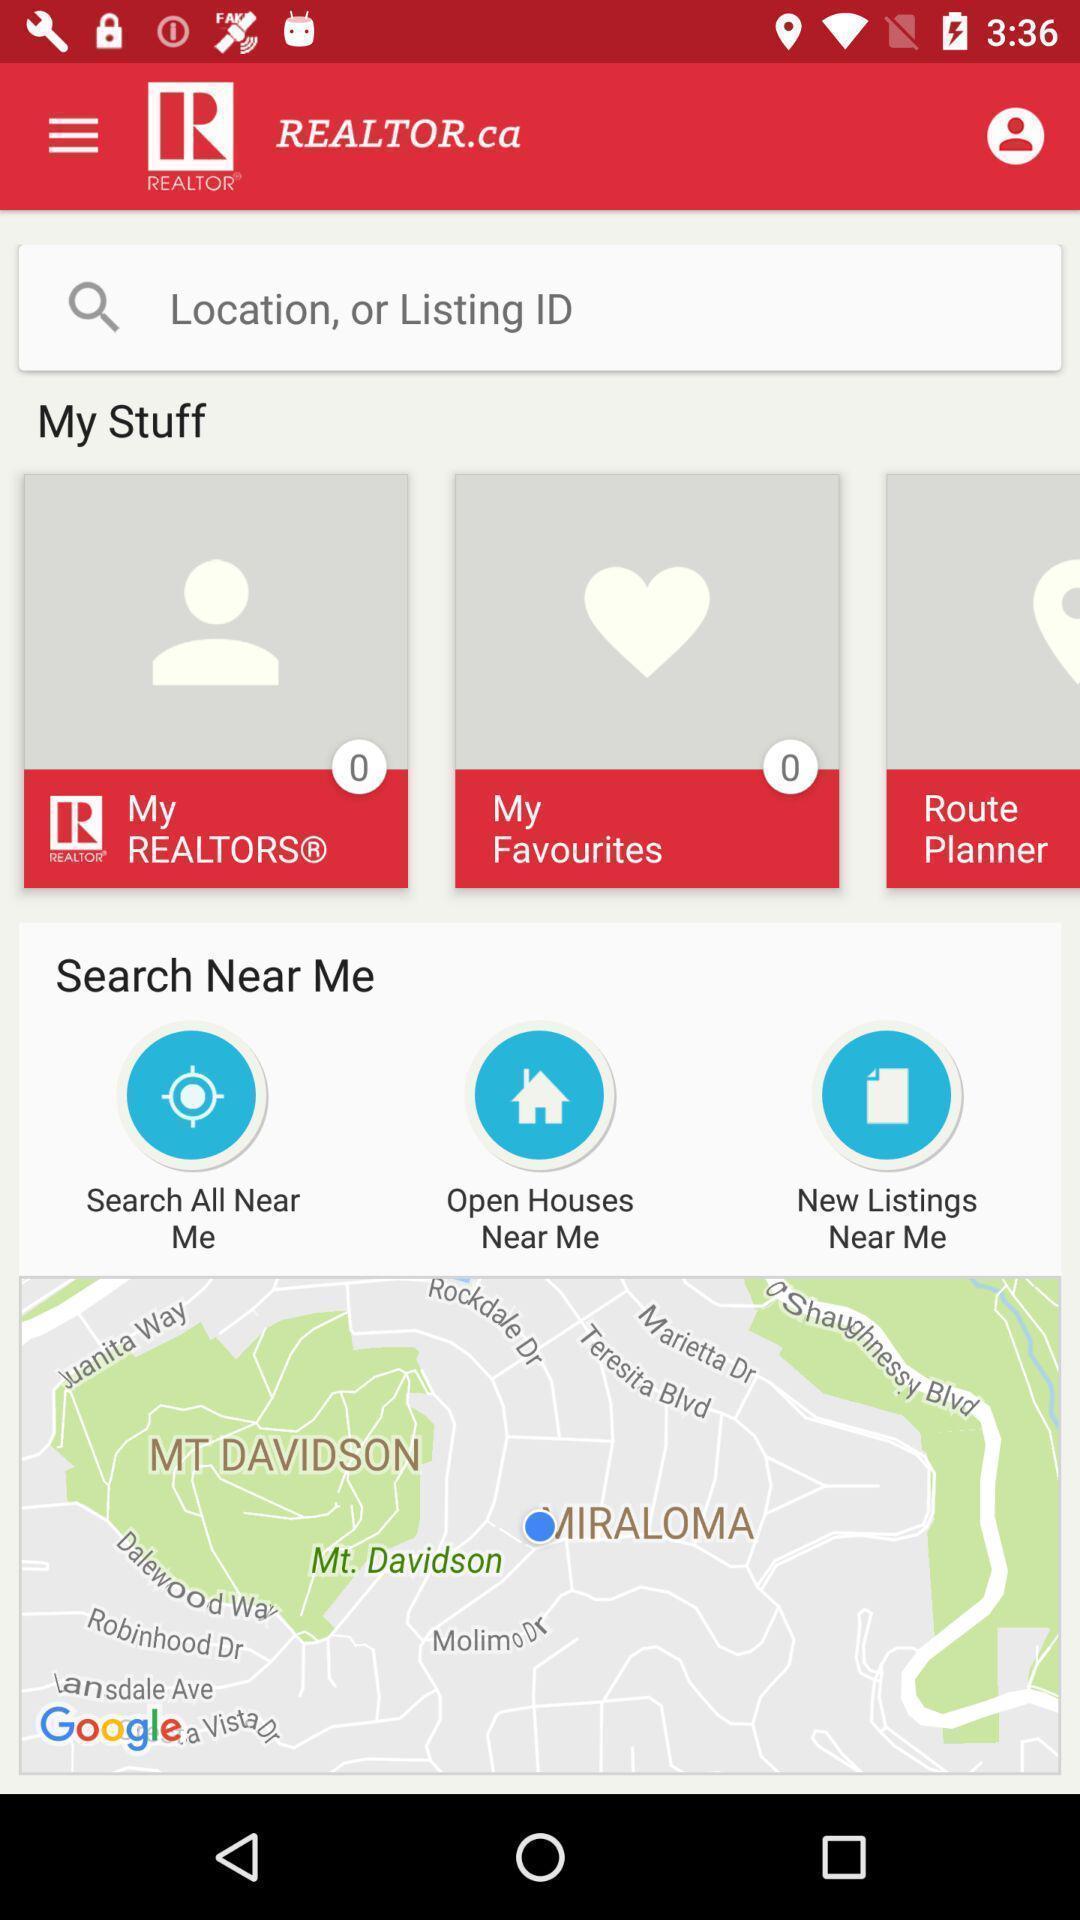Explain what's happening in this screen capture. Screen showing search bar to find locations nearby me. 